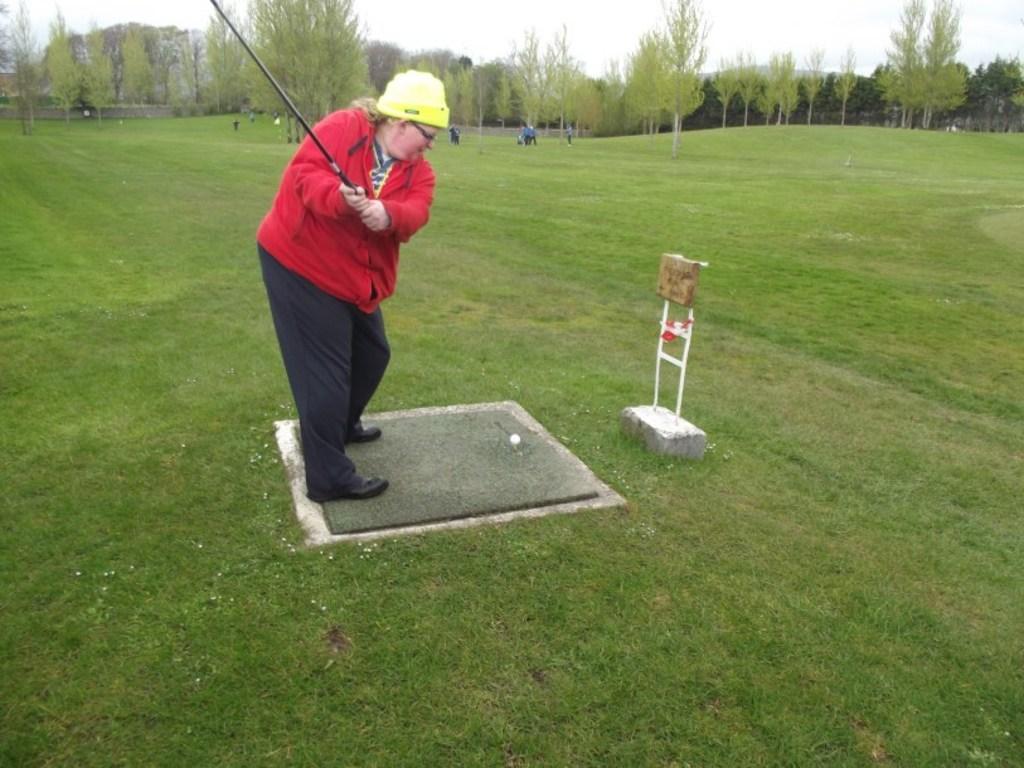In one or two sentences, can you explain what this image depicts? In the center of the image a lady is standing and holding a stick in her hand. In the background of the image we can see trees and some persons are there. At the bottom of the image grass is present. At the top of the image sky is there. 